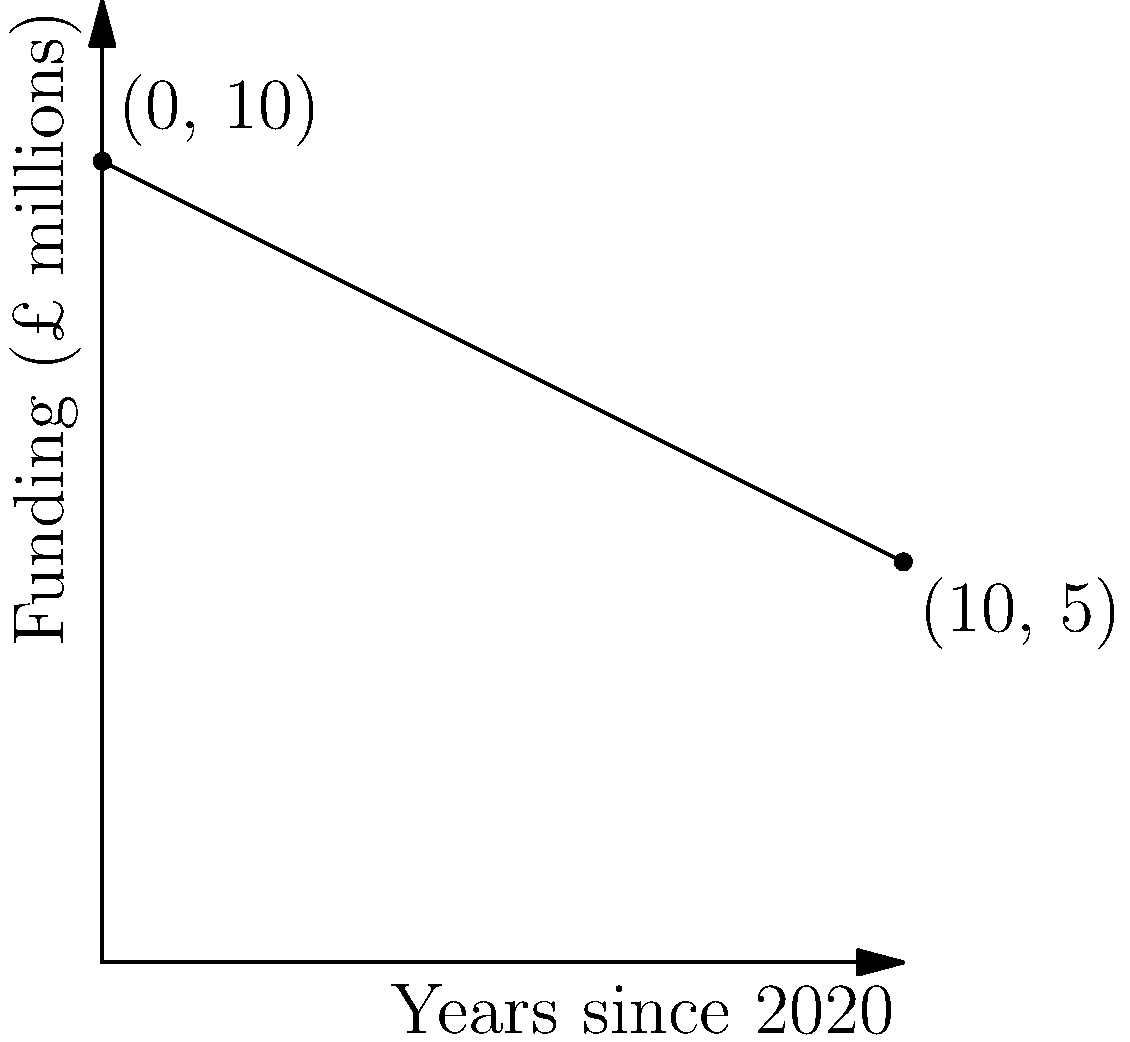The graph shows the declining funding for social programs in Lancashire over time. The coordinates (0, 10) represent the funding in 2020, and (10, 5) represent the projected funding in 2030. Calculate the slope of the line connecting these two points, which represents the annual rate of decline in funding. To calculate the slope of the line, we'll use the slope formula:

$$ \text{slope} = \frac{y_2 - y_1}{x_2 - x_1} $$

Where $(x_1, y_1)$ is the first point and $(x_2, y_2)$ is the second point.

1) Identify the points:
   $(x_1, y_1) = (0, 10)$ (funding in 2020)
   $(x_2, y_2) = (10, 5)$ (projected funding in 2030)

2) Substitute these values into the slope formula:

   $$ \text{slope} = \frac{5 - 10}{10 - 0} = \frac{-5}{10} $$

3) Simplify:

   $$ \text{slope} = -0.5 $$

This means that for each year that passes, the funding decreases by £0.5 million.
Answer: -0.5 